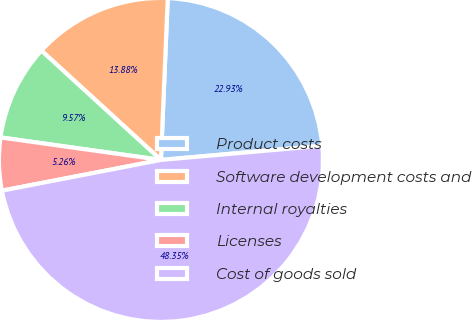Convert chart. <chart><loc_0><loc_0><loc_500><loc_500><pie_chart><fcel>Product costs<fcel>Software development costs and<fcel>Internal royalties<fcel>Licenses<fcel>Cost of goods sold<nl><fcel>22.93%<fcel>13.88%<fcel>9.57%<fcel>5.26%<fcel>48.35%<nl></chart> 